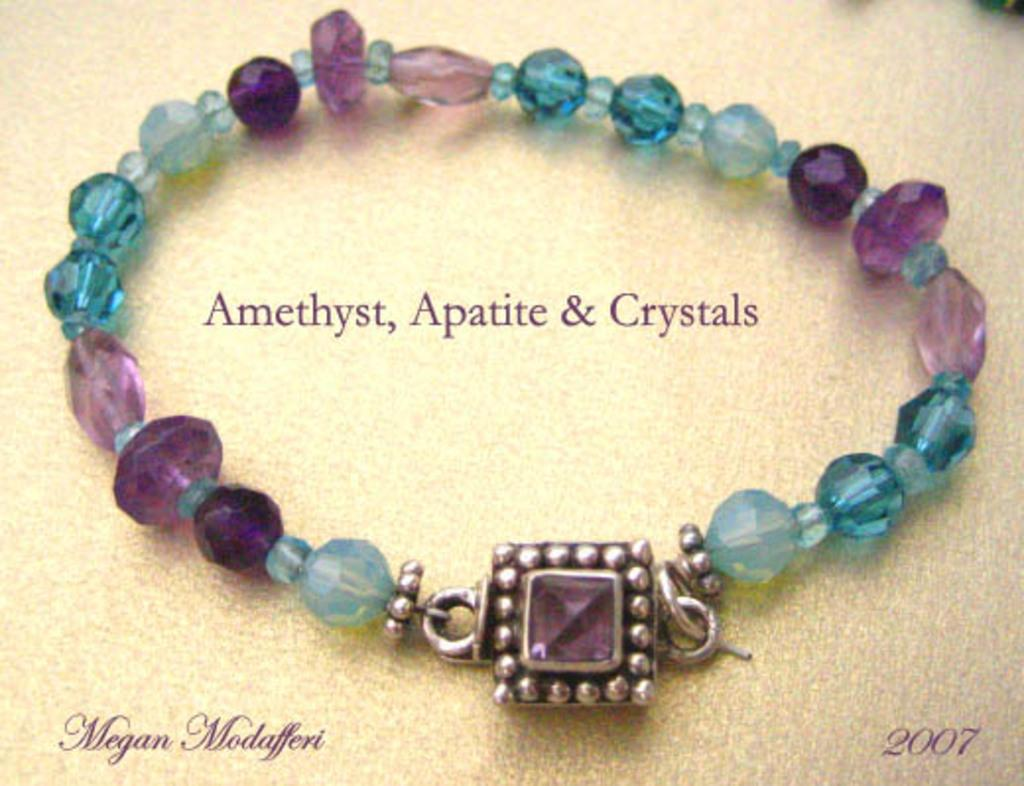What is the main subject of the image? There is a colorful bracelet in the image. How is the bracelet positioned in relation to other elements in the image? The bracelet is in front of other elements in the image. Are there any additional features present in the image? Yes, there are watermarks in the image. Can you describe the location of the watermarks? The watermarks are located on the left bottom, right, and middle of the image. What type of advertisement is being displayed on the bracelet in the image? There is no advertisement displayed on the bracelet in the image; it is simply a colorful bracelet. How does the bracelet help the person wearing it rest in the image? The bracelet does not have any direct impact on the person's ability to rest in the image; it is a decorative accessory. 